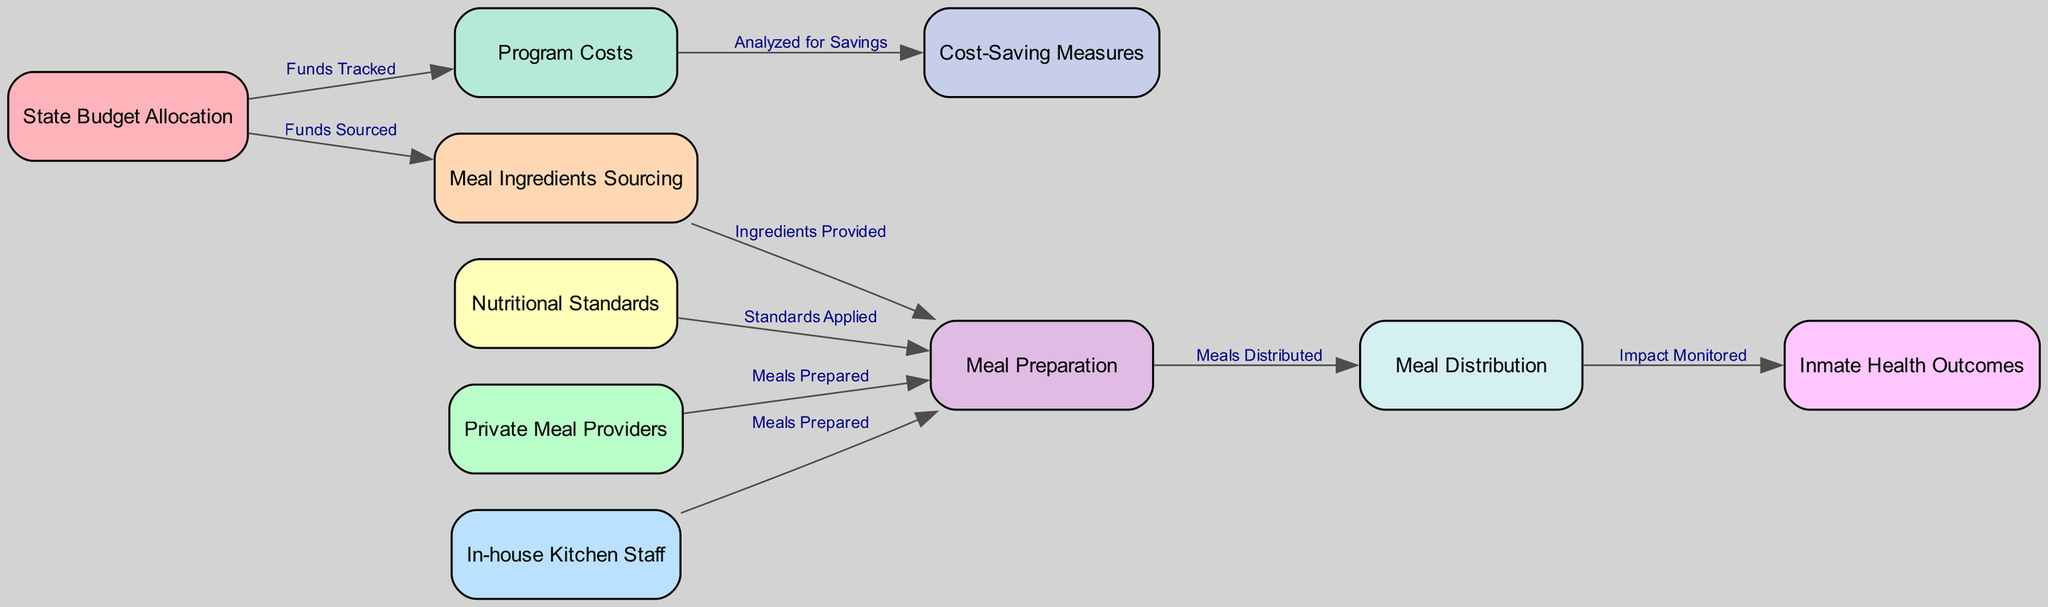What is allocated by the state government for prison meal programs? The diagram states that the "State Budget Allocation" represents the funds allocated by the state government for prison meal programs.
Answer: State Budget Allocation How many nodes are present in the diagram? By counting all unique nodes listed, there are ten distinct elements depicted in the diagram.
Answer: 10 Which nodes are responsible for the meal preparation? The diagram shows two sources for meal preparation: "Private Meal Providers" and "In-house Kitchen Staff". Both are indicated as having a direct role in this process.
Answer: Private Meal Providers, In-house Kitchen Staff What is monitored after meal distribution? The connection between "Meal Distribution" and "Inmate Health Outcomes" indicates that the impact of meals on inmate health is monitored following the distribution.
Answer: Impact Monitored What is a cost-saving strategy analyzed in the diagram? The "Cost-Saving Measures" node is directly connected to the "Program Costs," indicating this is the strategy used to reduce the expenditures on meal programs.
Answer: Cost-Saving Measures Which standards are applied during meal preparation? The diagram indicates that "Nutritional Standards" guide the process, ensuring meals meet required health guidelines in the preparation stage.
Answer: Nutritional Standards How does the state track funds used for meal programs? The edge leading from "State Budget Allocation" to "Program Costs" illustrates that funds are being tracked as part of the expense process related to meal programs.
Answer: Funds Tracked What is designed to measure the impact of meals on health? The "Inmate Health Outcomes" node is specifically designated to monitor and evaluate the health effects of the meal programs after meals are distributed.
Answer: Impact Monitored 